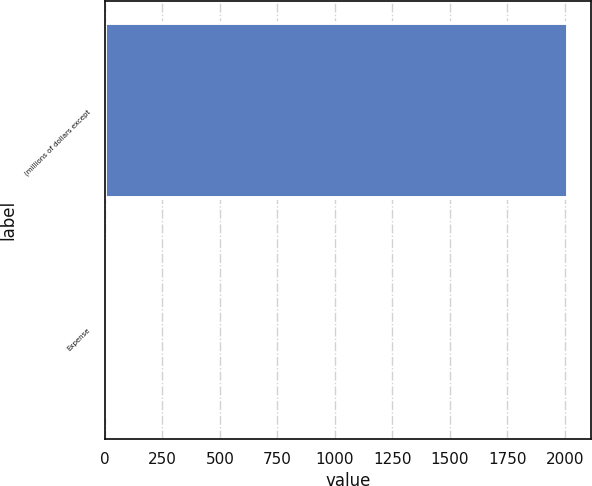<chart> <loc_0><loc_0><loc_500><loc_500><bar_chart><fcel>(millions of dollars except<fcel>Expense<nl><fcel>2015<fcel>12.2<nl></chart> 